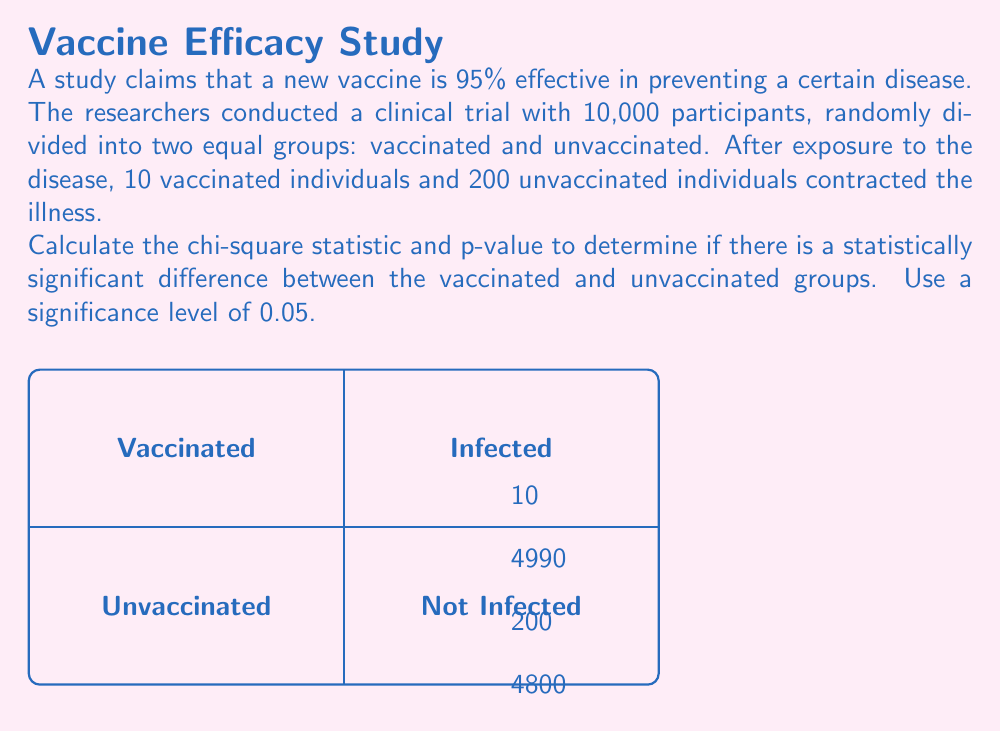Provide a solution to this math problem. Let's approach this step-by-step:

1) First, we need to set up our contingency table:

   | Infected | Not Infected | Total
---|---------|-------------|------
Vaccinated | 10 | 4990 | 5000
Unvaccinated | 200 | 4800 | 5000
Total | 210 | 9790 | 10000

2) The chi-square statistic is calculated using the formula:

   $$\chi^2 = \sum \frac{(O - E)^2}{E}$$

   where O is the observed frequency and E is the expected frequency.

3) To calculate the expected frequencies, we use:

   $$E = \frac{\text{row total} \times \text{column total}}{\text{grand total}}$$

   For vaccinated and infected: $E = \frac{5000 \times 210}{10000} = 105$
   For vaccinated and not infected: $E = \frac{5000 \times 9790}{10000} = 4895$
   For unvaccinated and infected: $E = \frac{5000 \times 210}{10000} = 105$
   For unvaccinated and not infected: $E = \frac{5000 \times 9790}{10000} = 4895$

4) Now we can calculate the chi-square statistic:

   $$\chi^2 = \frac{(10 - 105)^2}{105} + \frac{(4990 - 4895)^2}{4895} + \frac{(200 - 105)^2}{105} + \frac{(4800 - 4895)^2}{4895}$$
   
   $$\chi^2 = 86.19 + 1.85 + 86.19 + 1.85 = 176.08$$

5) The degrees of freedom for this 2x2 table is (2-1)(2-1) = 1.

6) Using a chi-square distribution table or calculator with 1 degree of freedom, we find that the p-value for $\chi^2 = 176.08$ is much smaller than 0.0001.

7) Since the p-value is less than our significance level of 0.05, we reject the null hypothesis.
Answer: $\chi^2 = 176.08$, p-value < 0.0001; statistically significant difference 